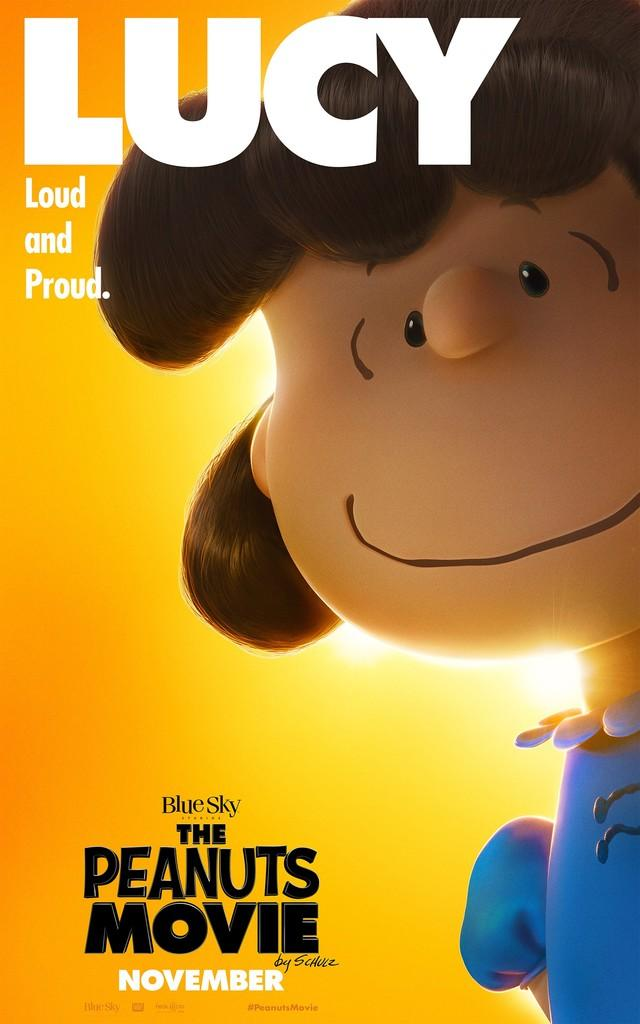<image>
Offer a succinct explanation of the picture presented. The Peanuts Movie by Blue Sky is out in November. 